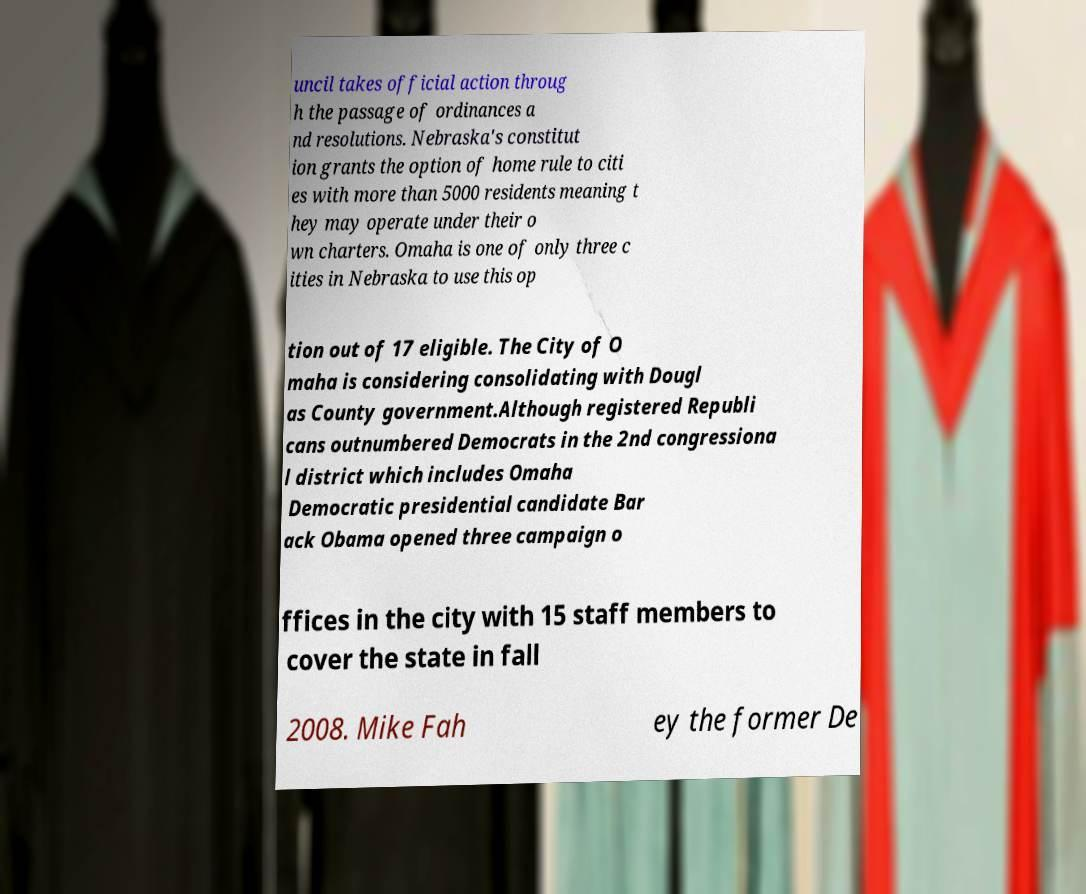I need the written content from this picture converted into text. Can you do that? uncil takes official action throug h the passage of ordinances a nd resolutions. Nebraska's constitut ion grants the option of home rule to citi es with more than 5000 residents meaning t hey may operate under their o wn charters. Omaha is one of only three c ities in Nebraska to use this op tion out of 17 eligible. The City of O maha is considering consolidating with Dougl as County government.Although registered Republi cans outnumbered Democrats in the 2nd congressiona l district which includes Omaha Democratic presidential candidate Bar ack Obama opened three campaign o ffices in the city with 15 staff members to cover the state in fall 2008. Mike Fah ey the former De 